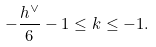<formula> <loc_0><loc_0><loc_500><loc_500>- \frac { h ^ { \vee } } { 6 } - 1 \leq k \leq - 1 .</formula> 